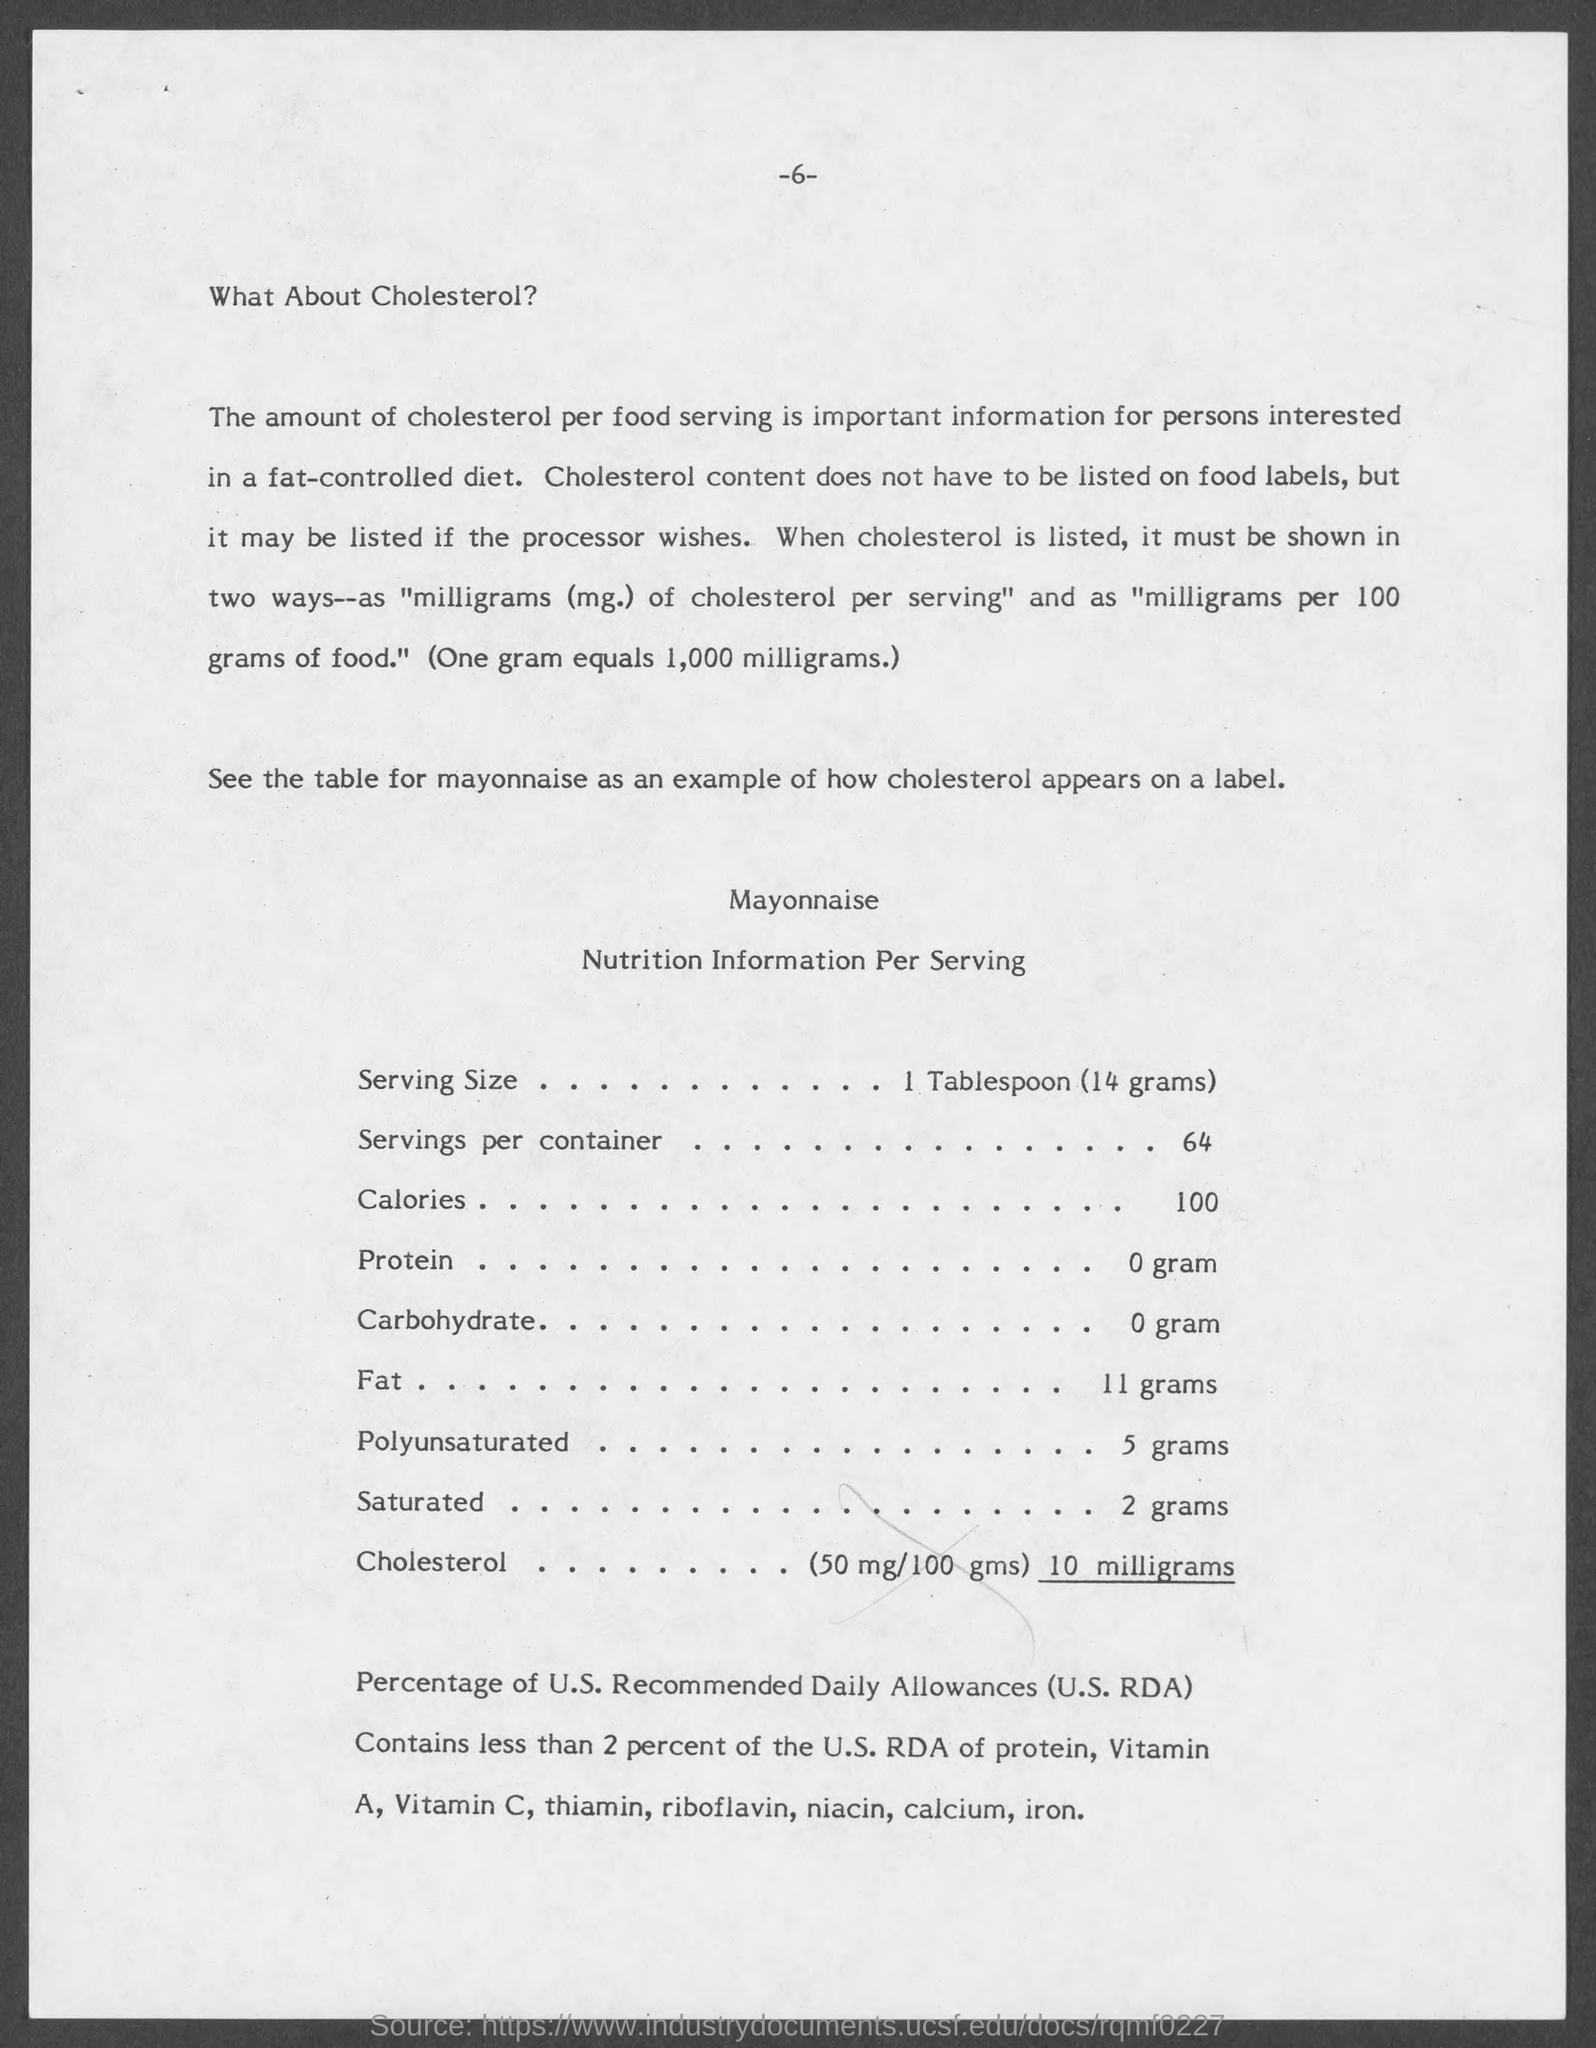Specify some key components in this picture. The number written at the center of the top page is 6. The serving size mentioned in the table is 1 tablespoon. It is important for individuals interested in a fat-controlled diet to be aware of the amount of cholesterol in each food serving. There are 1,000 milligrams in a gram. 